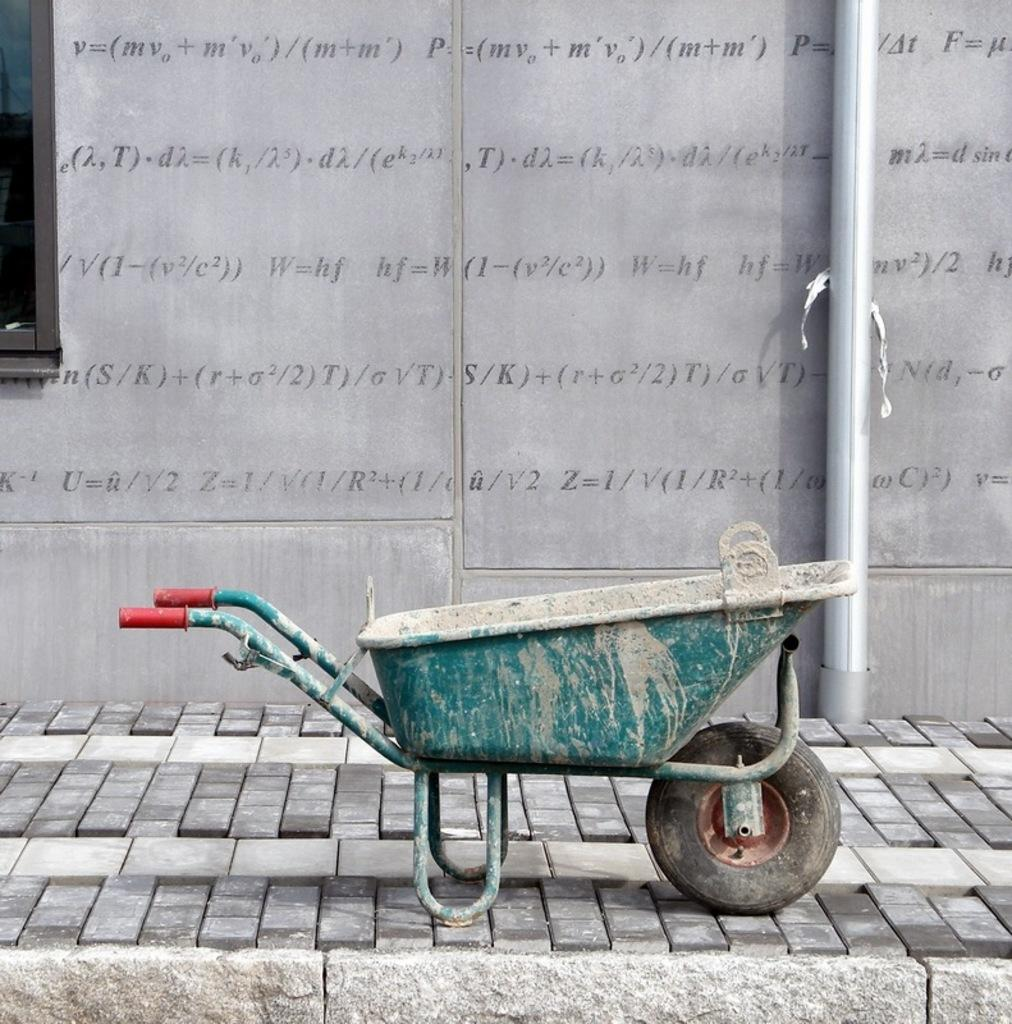What can be seen in the foreground of the image? There is a footpath and a trolley in the foreground of the image. What is visible in the background of the image? There is a window, a pipe, and a wall in the background of the image. What is written on the wall in the image? There is text on the wall in the image. How does the pipe curve in the image? The pipe does not curve in the image; it is a straight pipe. What type of toy can be seen rolling on the footpath in the image? There are no toys or rolling objects present in the image. 